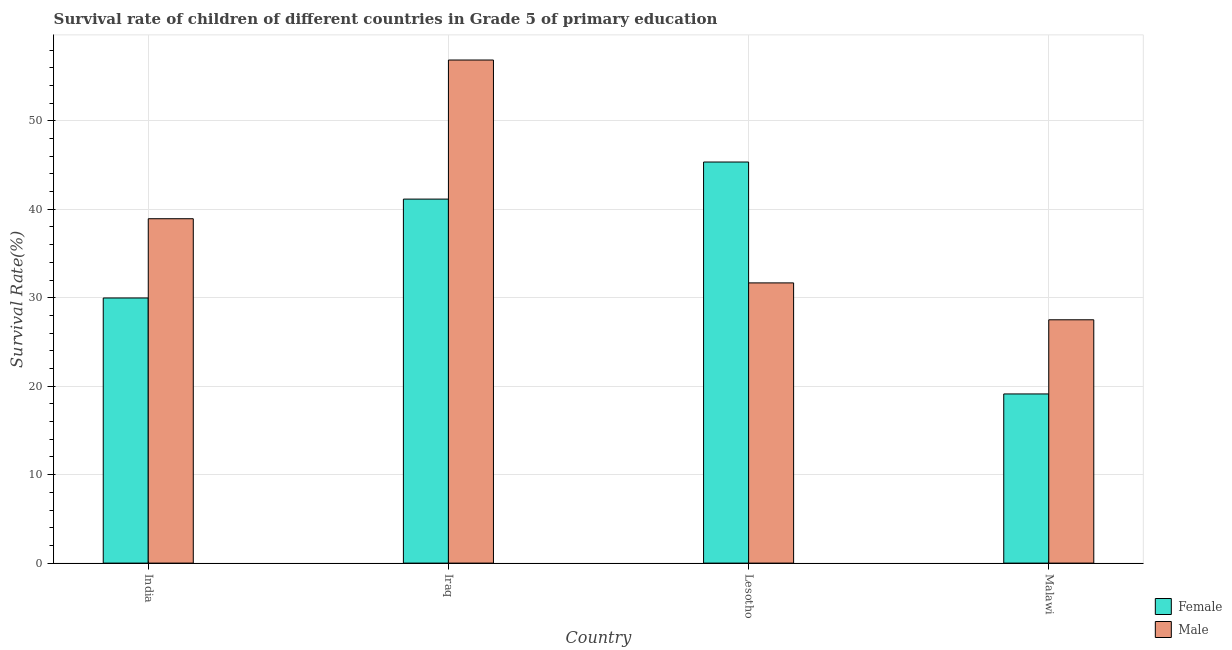How many different coloured bars are there?
Your answer should be very brief. 2. How many groups of bars are there?
Offer a terse response. 4. Are the number of bars on each tick of the X-axis equal?
Ensure brevity in your answer.  Yes. How many bars are there on the 2nd tick from the left?
Provide a short and direct response. 2. How many bars are there on the 2nd tick from the right?
Your answer should be very brief. 2. What is the label of the 3rd group of bars from the left?
Ensure brevity in your answer.  Lesotho. What is the survival rate of female students in primary education in India?
Provide a short and direct response. 29.97. Across all countries, what is the maximum survival rate of male students in primary education?
Make the answer very short. 56.88. Across all countries, what is the minimum survival rate of male students in primary education?
Ensure brevity in your answer.  27.51. In which country was the survival rate of male students in primary education maximum?
Your answer should be compact. Iraq. In which country was the survival rate of male students in primary education minimum?
Your answer should be very brief. Malawi. What is the total survival rate of female students in primary education in the graph?
Ensure brevity in your answer.  135.6. What is the difference between the survival rate of female students in primary education in Iraq and that in Malawi?
Offer a terse response. 22.03. What is the difference between the survival rate of female students in primary education in Lesotho and the survival rate of male students in primary education in India?
Give a very brief answer. 6.41. What is the average survival rate of male students in primary education per country?
Make the answer very short. 38.75. What is the difference between the survival rate of male students in primary education and survival rate of female students in primary education in India?
Your answer should be compact. 8.96. In how many countries, is the survival rate of female students in primary education greater than 52 %?
Your answer should be compact. 0. What is the ratio of the survival rate of female students in primary education in Iraq to that in Malawi?
Ensure brevity in your answer.  2.15. What is the difference between the highest and the second highest survival rate of female students in primary education?
Offer a very short reply. 4.19. What is the difference between the highest and the lowest survival rate of male students in primary education?
Your answer should be compact. 29.37. What does the 1st bar from the left in Iraq represents?
Your response must be concise. Female. Are all the bars in the graph horizontal?
Provide a succinct answer. No. How many countries are there in the graph?
Keep it short and to the point. 4. What is the difference between two consecutive major ticks on the Y-axis?
Your answer should be very brief. 10. Are the values on the major ticks of Y-axis written in scientific E-notation?
Your answer should be compact. No. How are the legend labels stacked?
Ensure brevity in your answer.  Vertical. What is the title of the graph?
Make the answer very short. Survival rate of children of different countries in Grade 5 of primary education. Does "Male labor force" appear as one of the legend labels in the graph?
Ensure brevity in your answer.  No. What is the label or title of the X-axis?
Give a very brief answer. Country. What is the label or title of the Y-axis?
Provide a short and direct response. Survival Rate(%). What is the Survival Rate(%) in Female in India?
Offer a terse response. 29.97. What is the Survival Rate(%) of Male in India?
Provide a short and direct response. 38.93. What is the Survival Rate(%) in Female in Iraq?
Make the answer very short. 41.15. What is the Survival Rate(%) in Male in Iraq?
Your response must be concise. 56.88. What is the Survival Rate(%) of Female in Lesotho?
Provide a succinct answer. 45.35. What is the Survival Rate(%) in Male in Lesotho?
Your answer should be very brief. 31.68. What is the Survival Rate(%) of Female in Malawi?
Make the answer very short. 19.12. What is the Survival Rate(%) of Male in Malawi?
Give a very brief answer. 27.51. Across all countries, what is the maximum Survival Rate(%) in Female?
Keep it short and to the point. 45.35. Across all countries, what is the maximum Survival Rate(%) of Male?
Ensure brevity in your answer.  56.88. Across all countries, what is the minimum Survival Rate(%) of Female?
Your answer should be very brief. 19.12. Across all countries, what is the minimum Survival Rate(%) of Male?
Your answer should be very brief. 27.51. What is the total Survival Rate(%) in Female in the graph?
Ensure brevity in your answer.  135.6. What is the total Survival Rate(%) of Male in the graph?
Keep it short and to the point. 155. What is the difference between the Survival Rate(%) in Female in India and that in Iraq?
Your answer should be compact. -11.18. What is the difference between the Survival Rate(%) in Male in India and that in Iraq?
Keep it short and to the point. -17.94. What is the difference between the Survival Rate(%) of Female in India and that in Lesotho?
Keep it short and to the point. -15.37. What is the difference between the Survival Rate(%) of Male in India and that in Lesotho?
Offer a very short reply. 7.26. What is the difference between the Survival Rate(%) of Female in India and that in Malawi?
Ensure brevity in your answer.  10.85. What is the difference between the Survival Rate(%) in Male in India and that in Malawi?
Make the answer very short. 11.43. What is the difference between the Survival Rate(%) of Female in Iraq and that in Lesotho?
Offer a very short reply. -4.19. What is the difference between the Survival Rate(%) of Male in Iraq and that in Lesotho?
Provide a succinct answer. 25.2. What is the difference between the Survival Rate(%) of Female in Iraq and that in Malawi?
Make the answer very short. 22.03. What is the difference between the Survival Rate(%) of Male in Iraq and that in Malawi?
Provide a succinct answer. 29.37. What is the difference between the Survival Rate(%) of Female in Lesotho and that in Malawi?
Make the answer very short. 26.22. What is the difference between the Survival Rate(%) of Male in Lesotho and that in Malawi?
Provide a short and direct response. 4.17. What is the difference between the Survival Rate(%) in Female in India and the Survival Rate(%) in Male in Iraq?
Keep it short and to the point. -26.9. What is the difference between the Survival Rate(%) in Female in India and the Survival Rate(%) in Male in Lesotho?
Offer a very short reply. -1.7. What is the difference between the Survival Rate(%) in Female in India and the Survival Rate(%) in Male in Malawi?
Offer a terse response. 2.47. What is the difference between the Survival Rate(%) in Female in Iraq and the Survival Rate(%) in Male in Lesotho?
Your response must be concise. 9.47. What is the difference between the Survival Rate(%) of Female in Iraq and the Survival Rate(%) of Male in Malawi?
Offer a terse response. 13.64. What is the difference between the Survival Rate(%) of Female in Lesotho and the Survival Rate(%) of Male in Malawi?
Provide a short and direct response. 17.84. What is the average Survival Rate(%) of Female per country?
Keep it short and to the point. 33.9. What is the average Survival Rate(%) in Male per country?
Your answer should be compact. 38.75. What is the difference between the Survival Rate(%) in Female and Survival Rate(%) in Male in India?
Provide a short and direct response. -8.96. What is the difference between the Survival Rate(%) of Female and Survival Rate(%) of Male in Iraq?
Make the answer very short. -15.72. What is the difference between the Survival Rate(%) in Female and Survival Rate(%) in Male in Lesotho?
Your answer should be compact. 13.67. What is the difference between the Survival Rate(%) of Female and Survival Rate(%) of Male in Malawi?
Provide a short and direct response. -8.38. What is the ratio of the Survival Rate(%) in Female in India to that in Iraq?
Provide a short and direct response. 0.73. What is the ratio of the Survival Rate(%) in Male in India to that in Iraq?
Make the answer very short. 0.68. What is the ratio of the Survival Rate(%) in Female in India to that in Lesotho?
Make the answer very short. 0.66. What is the ratio of the Survival Rate(%) in Male in India to that in Lesotho?
Make the answer very short. 1.23. What is the ratio of the Survival Rate(%) in Female in India to that in Malawi?
Keep it short and to the point. 1.57. What is the ratio of the Survival Rate(%) of Male in India to that in Malawi?
Make the answer very short. 1.42. What is the ratio of the Survival Rate(%) in Female in Iraq to that in Lesotho?
Your response must be concise. 0.91. What is the ratio of the Survival Rate(%) in Male in Iraq to that in Lesotho?
Provide a succinct answer. 1.8. What is the ratio of the Survival Rate(%) in Female in Iraq to that in Malawi?
Offer a terse response. 2.15. What is the ratio of the Survival Rate(%) of Male in Iraq to that in Malawi?
Offer a terse response. 2.07. What is the ratio of the Survival Rate(%) in Female in Lesotho to that in Malawi?
Ensure brevity in your answer.  2.37. What is the ratio of the Survival Rate(%) of Male in Lesotho to that in Malawi?
Make the answer very short. 1.15. What is the difference between the highest and the second highest Survival Rate(%) of Female?
Make the answer very short. 4.19. What is the difference between the highest and the second highest Survival Rate(%) in Male?
Offer a very short reply. 17.94. What is the difference between the highest and the lowest Survival Rate(%) in Female?
Keep it short and to the point. 26.22. What is the difference between the highest and the lowest Survival Rate(%) of Male?
Your answer should be compact. 29.37. 